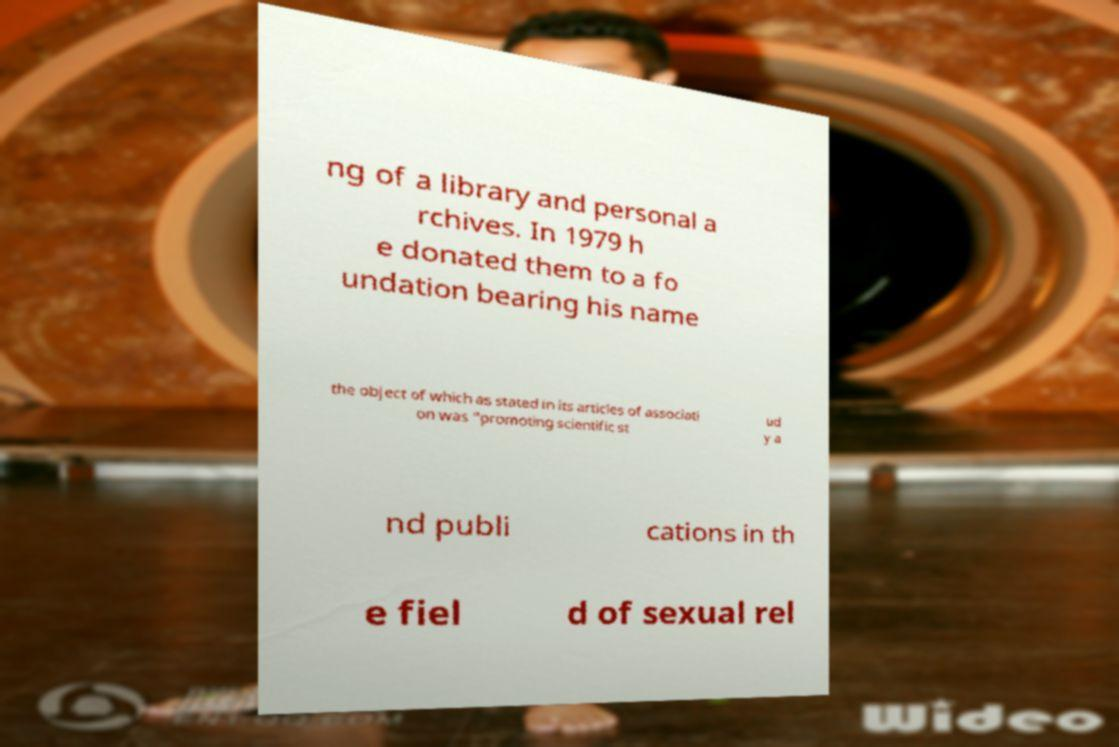Please identify and transcribe the text found in this image. ng of a library and personal a rchives. In 1979 h e donated them to a fo undation bearing his name the object of which as stated in its articles of associati on was "promoting scientific st ud y a nd publi cations in th e fiel d of sexual rel 